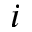Convert formula to latex. <formula><loc_0><loc_0><loc_500><loc_500>i</formula> 